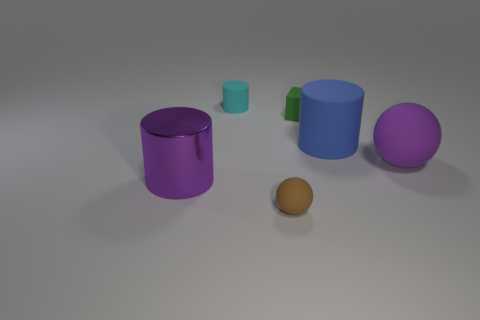There is another large thing that is the same shape as the big purple shiny object; what color is it? The large object that shares its cylindrical shape with the big purple one is blue, displaying a similar glossy finish and contributing to the image's array of cool tones. 